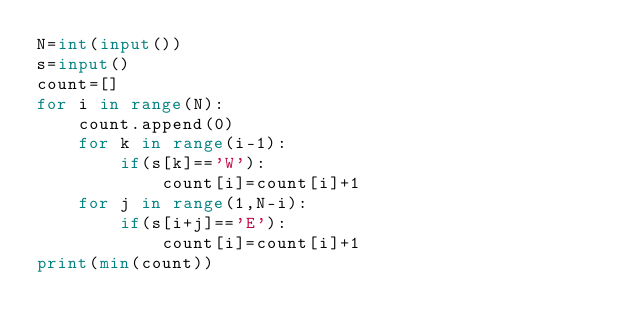<code> <loc_0><loc_0><loc_500><loc_500><_Python_>N=int(input())
s=input()
count=[]
for i in range(N):
    count.append(0)
    for k in range(i-1):
        if(s[k]=='W'):
            count[i]=count[i]+1
    for j in range(1,N-i):
        if(s[i+j]=='E'):
            count[i]=count[i]+1
print(min(count))</code> 